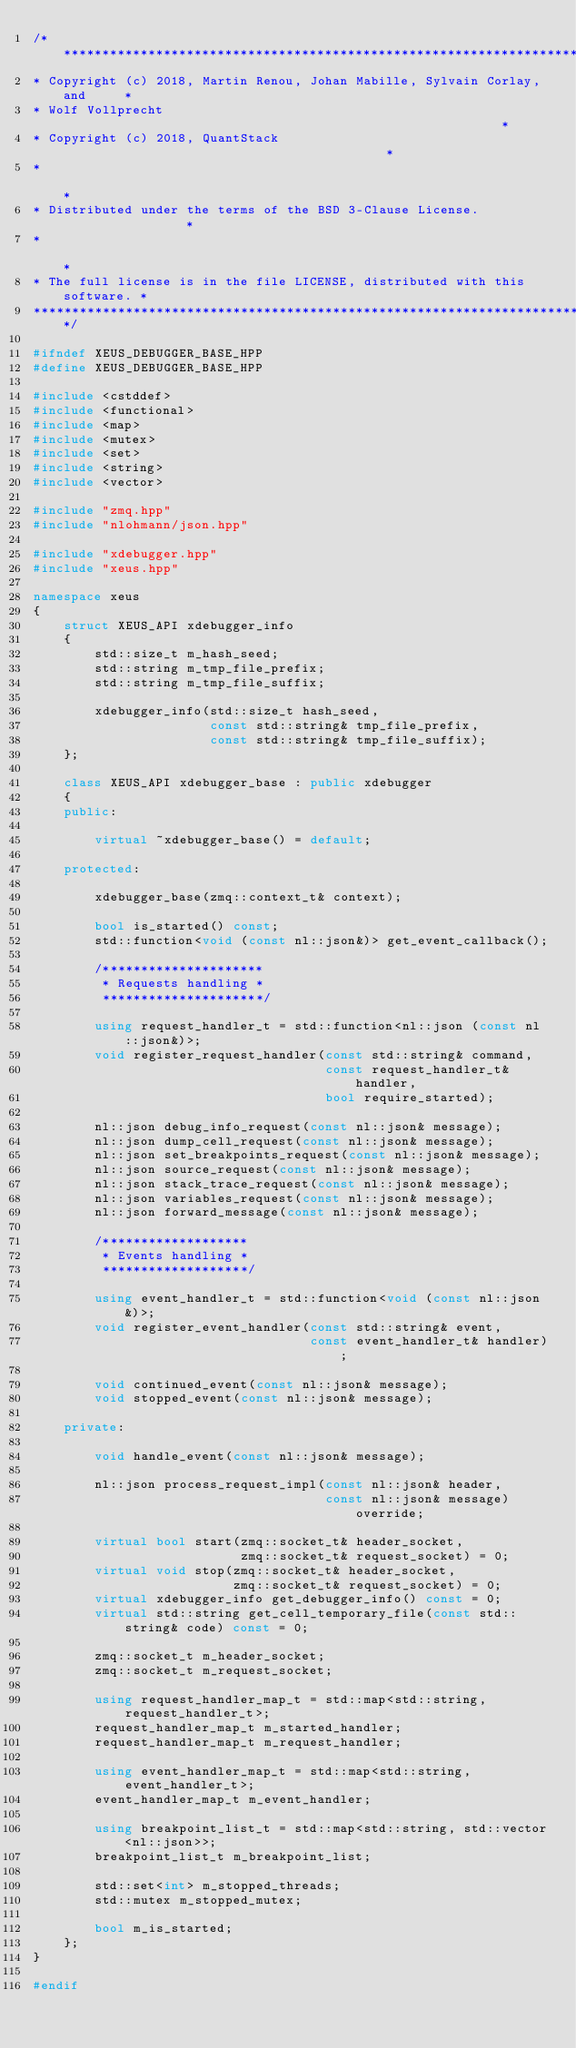<code> <loc_0><loc_0><loc_500><loc_500><_C++_>/***************************************************************************
* Copyright (c) 2018, Martin Renou, Johan Mabille, Sylvain Corlay, and     *
* Wolf Vollprecht                                                          *
* Copyright (c) 2018, QuantStack                                           *
*                                                                          *
* Distributed under the terms of the BSD 3-Clause License.                 *
*                                                                          *
* The full license is in the file LICENSE, distributed with this software. *
****************************************************************************/

#ifndef XEUS_DEBUGGER_BASE_HPP
#define XEUS_DEBUGGER_BASE_HPP

#include <cstddef>
#include <functional>
#include <map>
#include <mutex>
#include <set>
#include <string>
#include <vector>

#include "zmq.hpp"
#include "nlohmann/json.hpp"

#include "xdebugger.hpp"
#include "xeus.hpp"

namespace xeus
{
    struct XEUS_API xdebugger_info
    {
        std::size_t m_hash_seed;
        std::string m_tmp_file_prefix;
        std::string m_tmp_file_suffix;

        xdebugger_info(std::size_t hash_seed,
                       const std::string& tmp_file_prefix,
                       const std::string& tmp_file_suffix);
    };

    class XEUS_API xdebugger_base : public xdebugger
    {
    public:

        virtual ~xdebugger_base() = default;
        
    protected:

        xdebugger_base(zmq::context_t& context);

        bool is_started() const;
        std::function<void (const nl::json&)> get_event_callback();

        /*********************
         * Requests handling *
         *********************/

        using request_handler_t = std::function<nl::json (const nl::json&)>;
        void register_request_handler(const std::string& command,
                                      const request_handler_t& handler,
                                      bool require_started);

        nl::json debug_info_request(const nl::json& message);
        nl::json dump_cell_request(const nl::json& message);
        nl::json set_breakpoints_request(const nl::json& message);
        nl::json source_request(const nl::json& message);
        nl::json stack_trace_request(const nl::json& message);
        nl::json variables_request(const nl::json& message);
        nl::json forward_message(const nl::json& message);

        /*******************
         * Events handling *
         *******************/

        using event_handler_t = std::function<void (const nl::json&)>;
        void register_event_handler(const std::string& event,
                                    const event_handler_t& handler);

        void continued_event(const nl::json& message);
        void stopped_event(const nl::json& message);

    private:

        void handle_event(const nl::json& message);

        nl::json process_request_impl(const nl::json& header,
                                      const nl::json& message) override;

        virtual bool start(zmq::socket_t& header_socket,
                           zmq::socket_t& request_socket) = 0;
        virtual void stop(zmq::socket_t& header_socket,
                          zmq::socket_t& request_socket) = 0;
        virtual xdebugger_info get_debugger_info() const = 0;
        virtual std::string get_cell_temporary_file(const std::string& code) const = 0;

        zmq::socket_t m_header_socket;
        zmq::socket_t m_request_socket;
        
        using request_handler_map_t = std::map<std::string, request_handler_t>;
        request_handler_map_t m_started_handler;
        request_handler_map_t m_request_handler;

        using event_handler_map_t = std::map<std::string, event_handler_t>;
        event_handler_map_t m_event_handler;

        using breakpoint_list_t = std::map<std::string, std::vector<nl::json>>;
        breakpoint_list_t m_breakpoint_list;

        std::set<int> m_stopped_threads;
        std::mutex m_stopped_mutex;

        bool m_is_started;
    };
}

#endif

</code> 